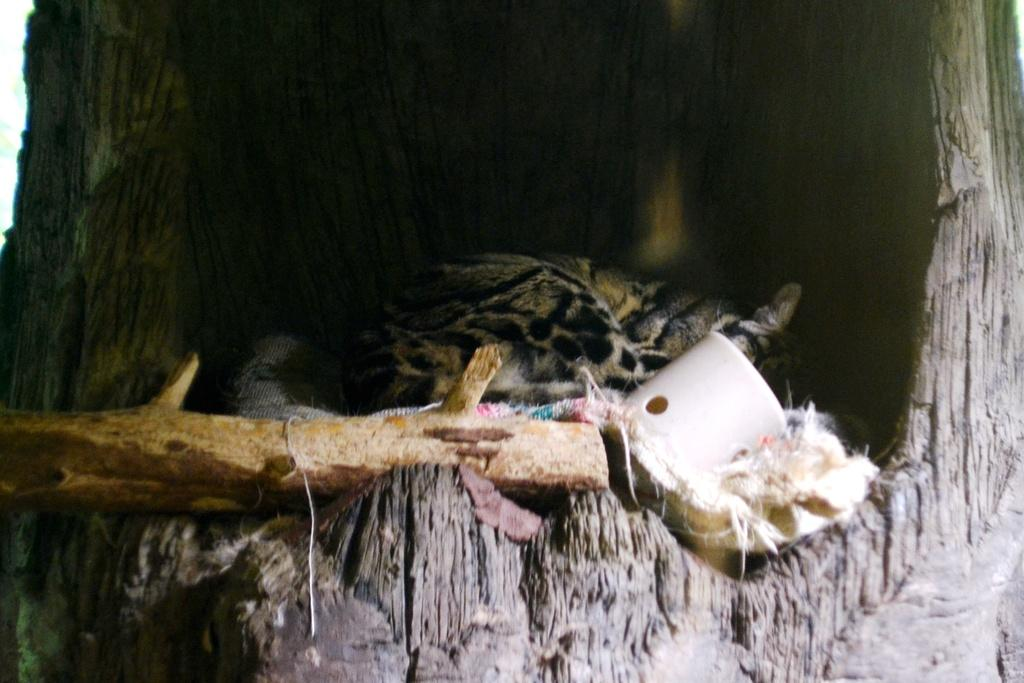What type of animal can be seen in the image? There is an animal in the image, with black and brown coloring. What else is visible in the image besides the animal? There are objects visible in the image. Can you describe one of the objects in the image? There is a wooden stick in the image. Where are the animal and objects located in the image? The animal, objects, and wooden stick are inside a truck. How many rings can be seen on the animal's nose in the image? There are no rings visible on the animal's nose in the image, as the animal does not have a nose ring. 